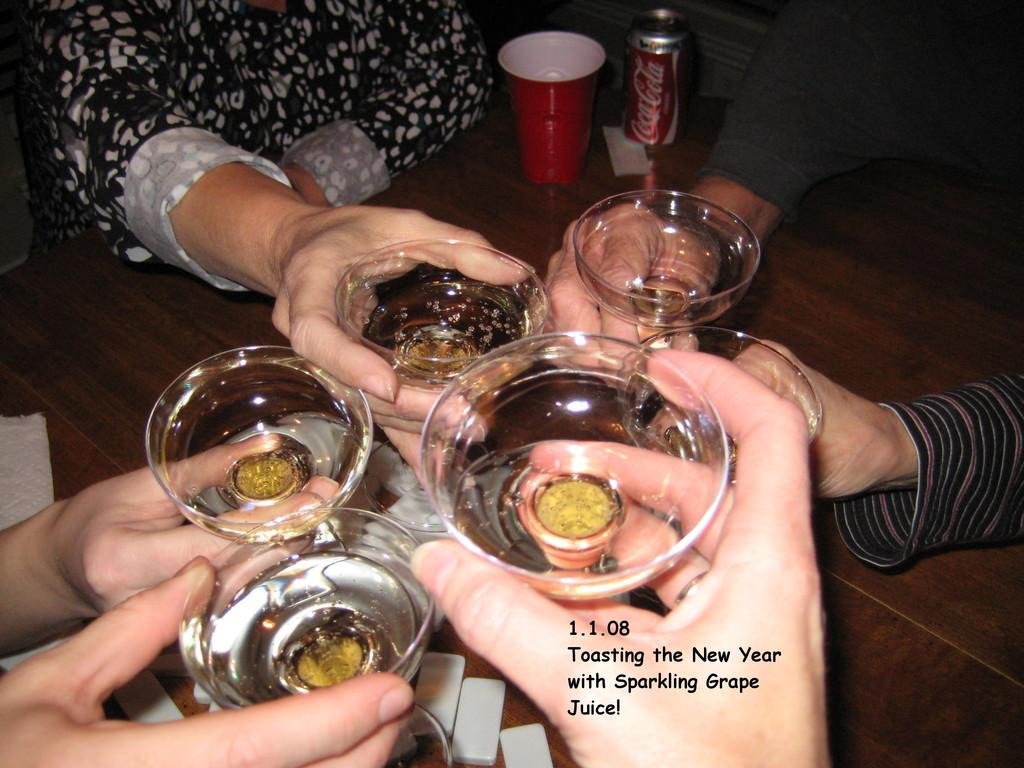What objects are present in the image that people might be holding? There are many glasses in the image, and people are holding the glasses. Can you describe the positioning of the glasses in the image? The glasses are being held by people in the image. What is located at the top of the image? There is a tin at the top of the image. What type of channel can be seen running through the glasses in the image? There is no channel visible running through the glasses in the image. Are there any trains present in the image? There are no trains present in the image. 